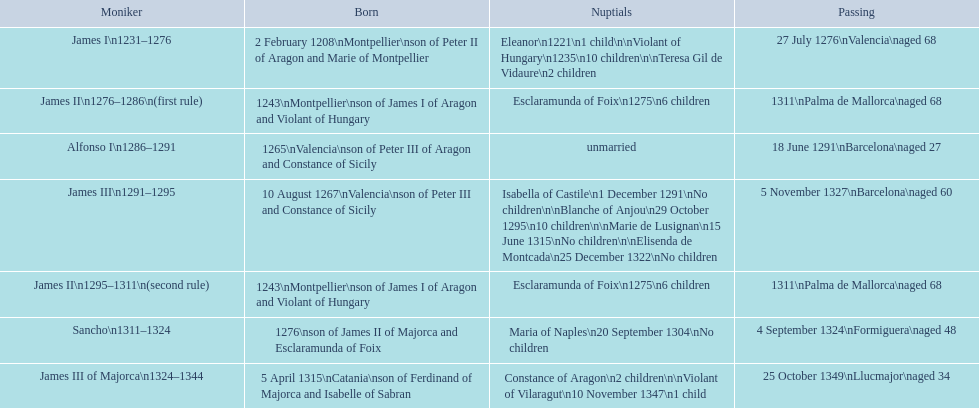Which monarch had the most marriages? James III 1291-1295. 